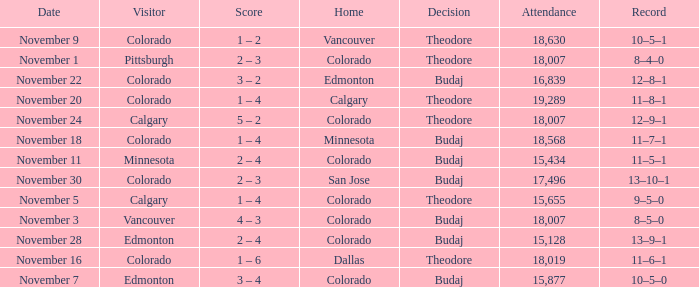Who was the Home Team while Calgary was visiting while having an Attendance above 15,655? Colorado. 